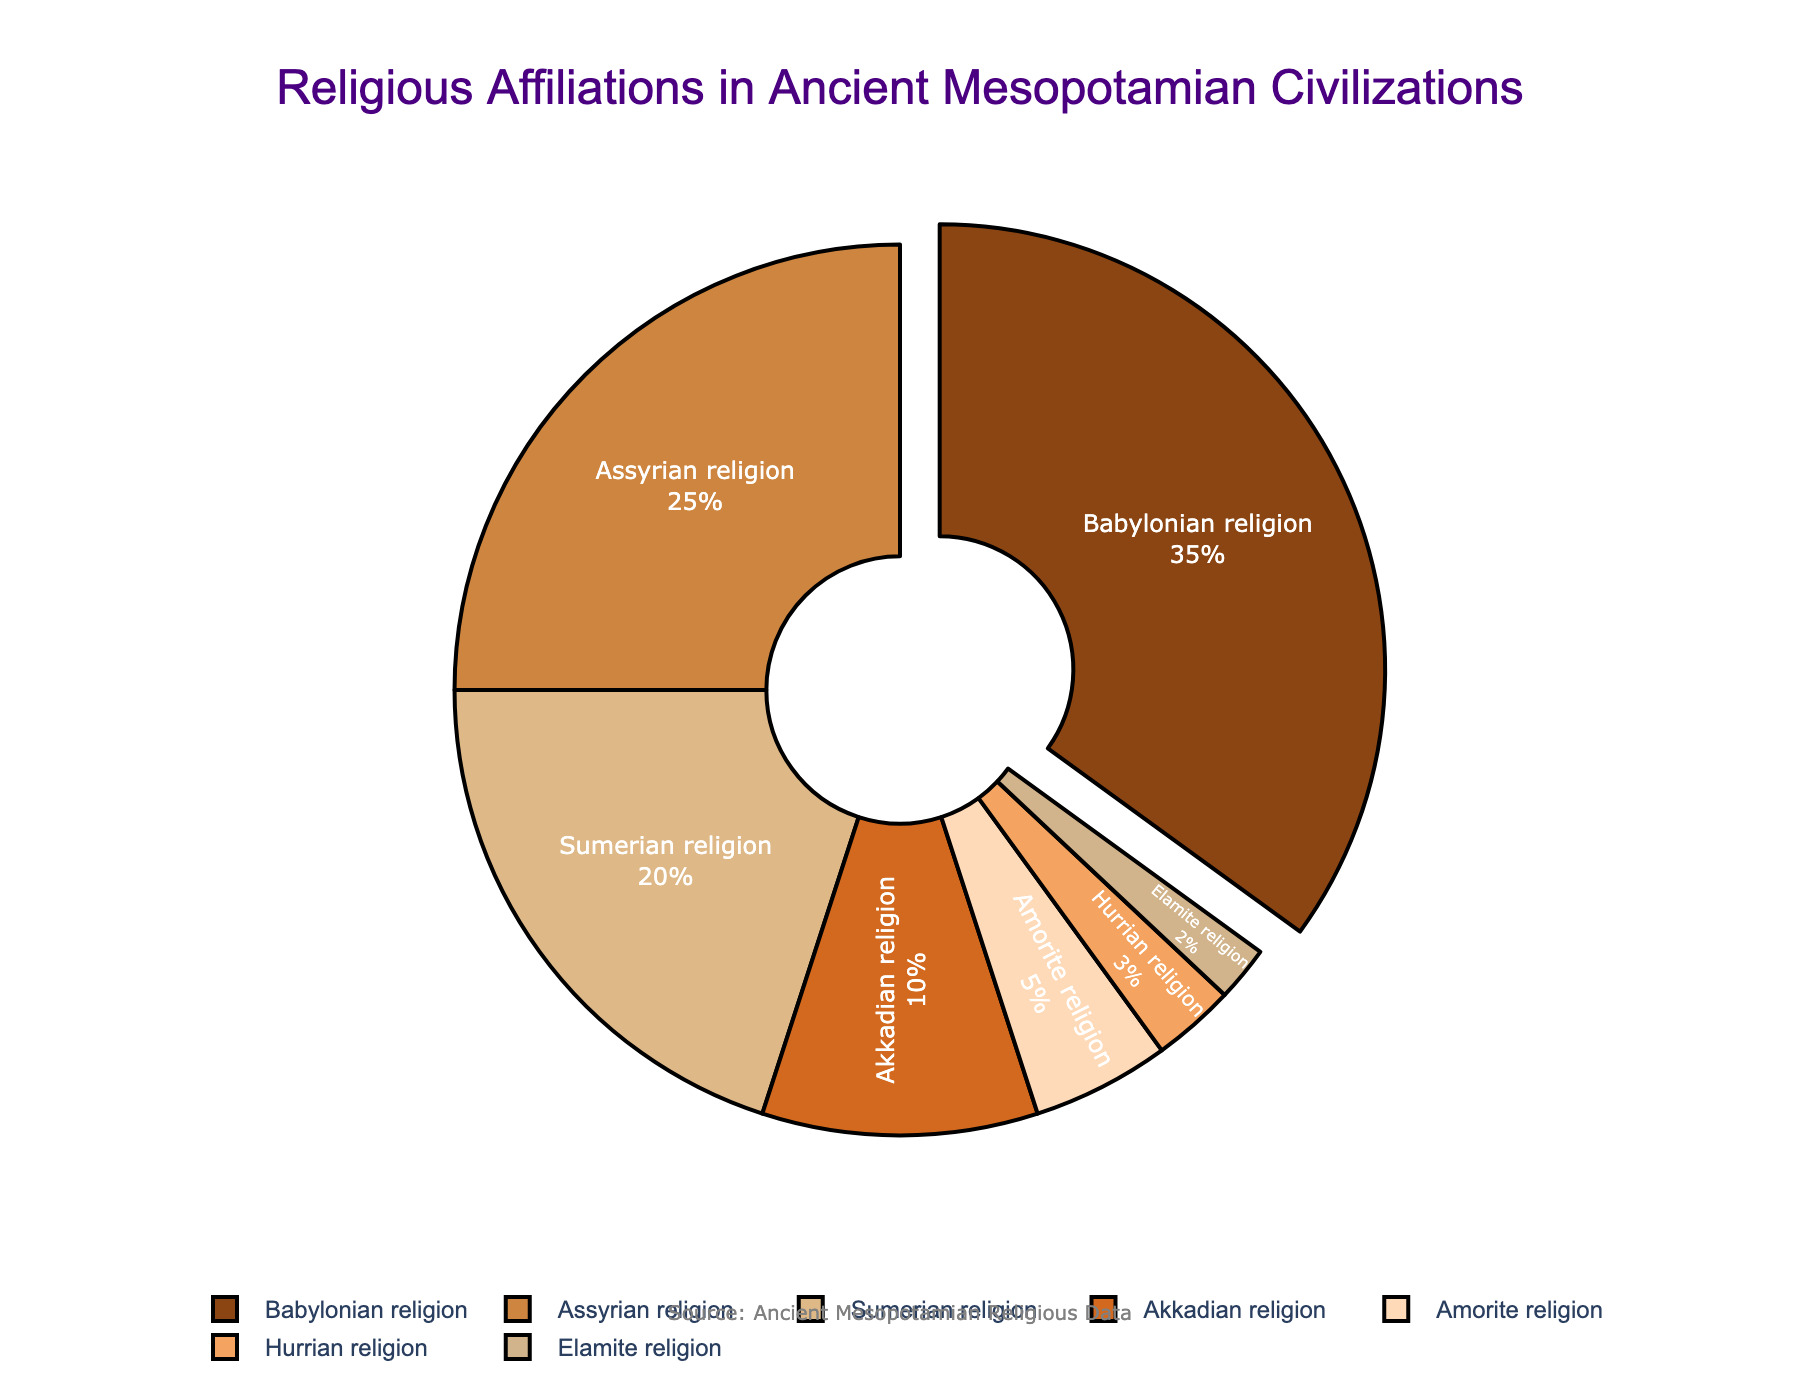What religion has the highest percentage? Look at the slice of the pie chart that is the largest. The label will indicate which religion it is.
Answer: Babylonian religion How much more is the percentage of the Babylonian religion compared to the Amorite religion? Find the percentage for both religions: Babylonian (35%) and Amorite (5%). Subtract the smaller percentage from the larger one: 35% - 5% = 30%.
Answer: 30% Which religion has the least percentage? Look for the smallest slice in the pie chart and check the label for that slice.
Answer: Elamite religion What is the combined percentage of the Sumerian and Akkadian religions? Identify the percentages for both religions: Sumerian (20%) and Akkadian (10%). Add the two percentages together: 20% + 10% = 30%.
Answer: 30% What religion is represented by the light brown color in the chart? Identify the slice of the pie chart with the light brown color and check the label attached to that slice.
Answer: Assyrian religion What is the difference in percentage between the Assyrian and Hurrian religions? Find the percentages for the Assyrian (25%) and Hurrian (3%) religions. Subtract the smaller percentage from the larger one: 25% - 3% = 22%.
Answer: 22% What percentage of religions other than the Babylonian and Assyrian religions make up the total? Exclude the percentages of the Babylonian (35%) and Assyrian (25%) religions from the total (100%): 100% - 35% - 25% = 40%.
Answer: 40% Which religions collectively constitute more than half of the pie chart? Identify the religions and their respective percentages and sum those that make up more than 50%. Babylonian (35%) + Assyrian (25%) = 60%.
Answer: Babylonian and Assyrian religions What is the total percentage of the Amorite, Hurrian, and Elamite religions combined? Add the percentages of Amorite (5%), Hurrian (3%), and Elamite (2%) religions: 5% + 3% + 2% = 10%.
Answer: 10% Does any religion in the pie chart have a percentage equal to or less than 5%? If so, which one? Check the percentages listed in the pie chart for any values that are 5% or less.
Answer: Amorite, Hurrian, and Elamite religions 